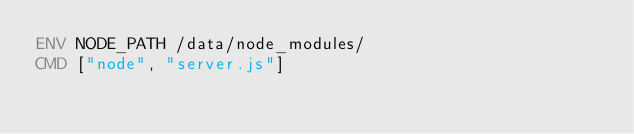Convert code to text. <code><loc_0><loc_0><loc_500><loc_500><_Dockerfile_>ENV NODE_PATH /data/node_modules/
CMD ["node", "server.js"]
</code> 